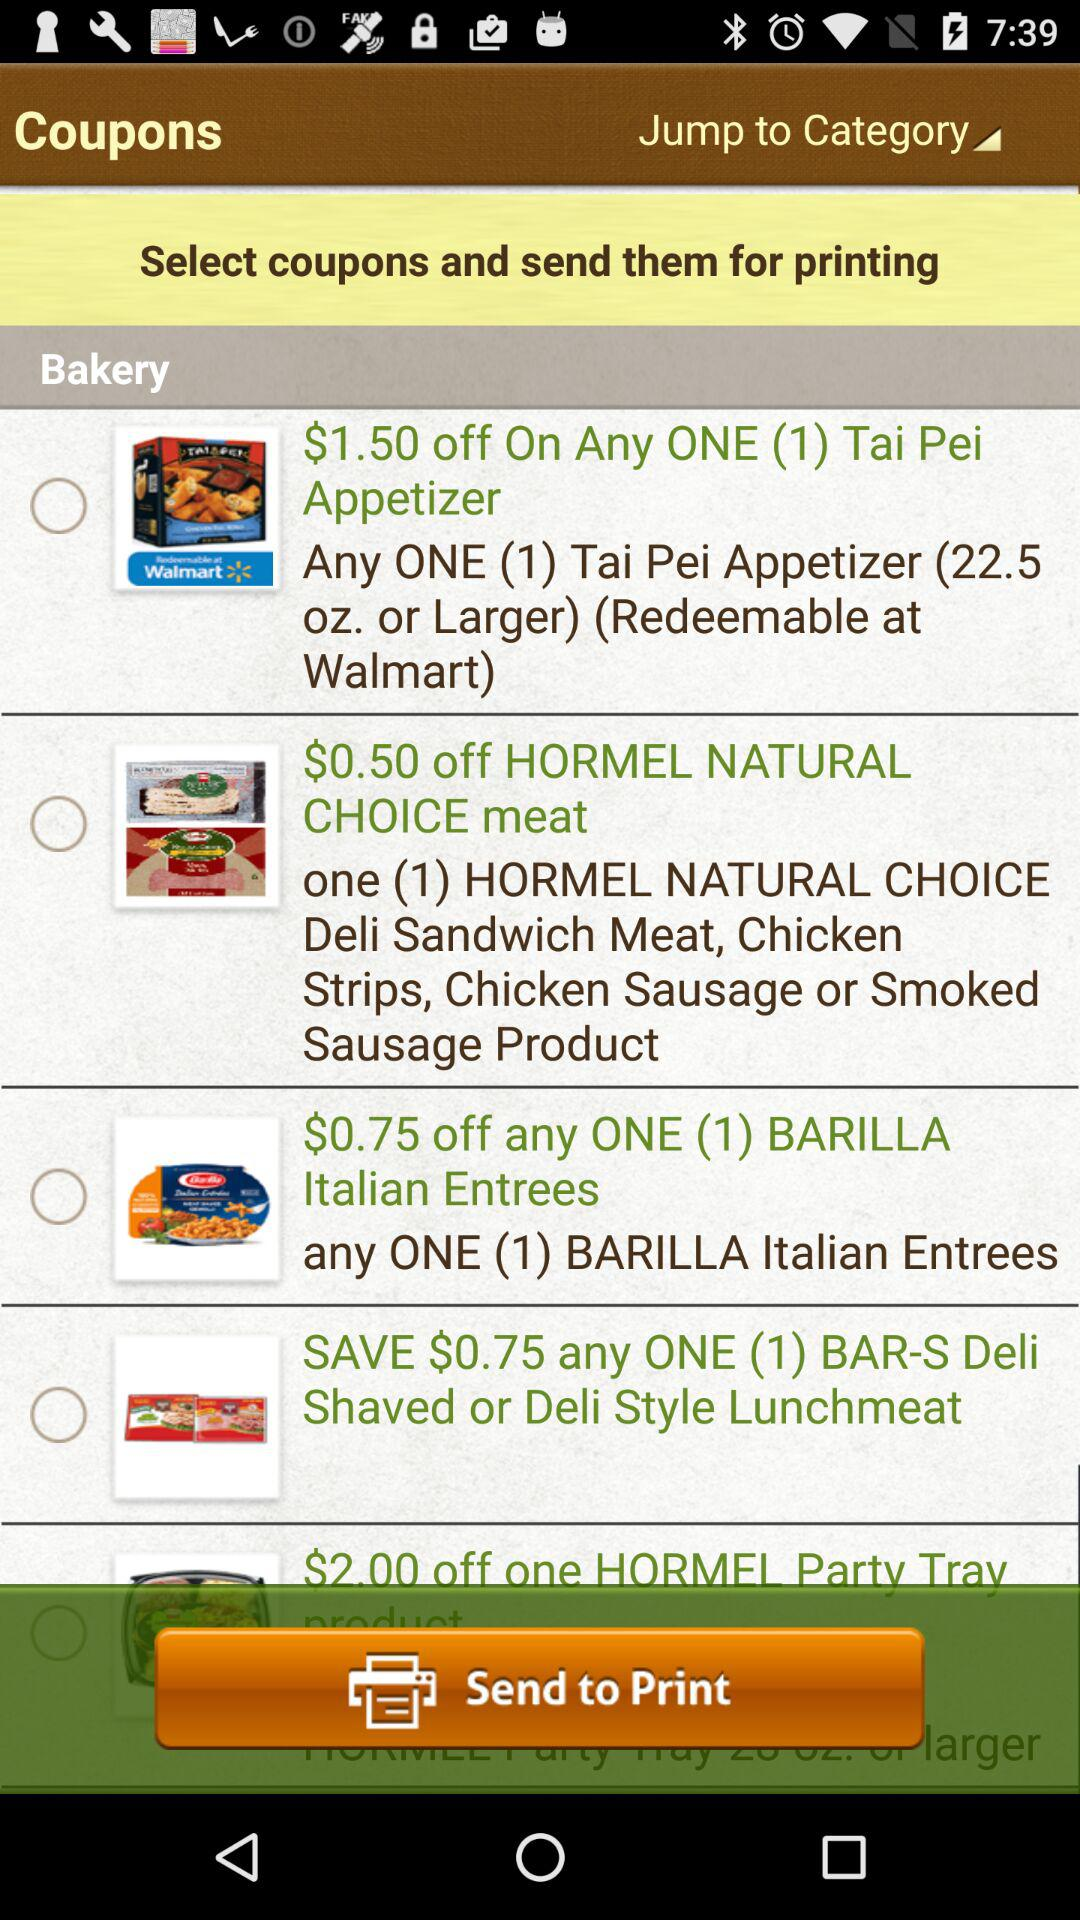What is the discount on one "BARILLA Italian Entrees"? The discount on one "BARILLA Italian Entrees" is $0.75. 